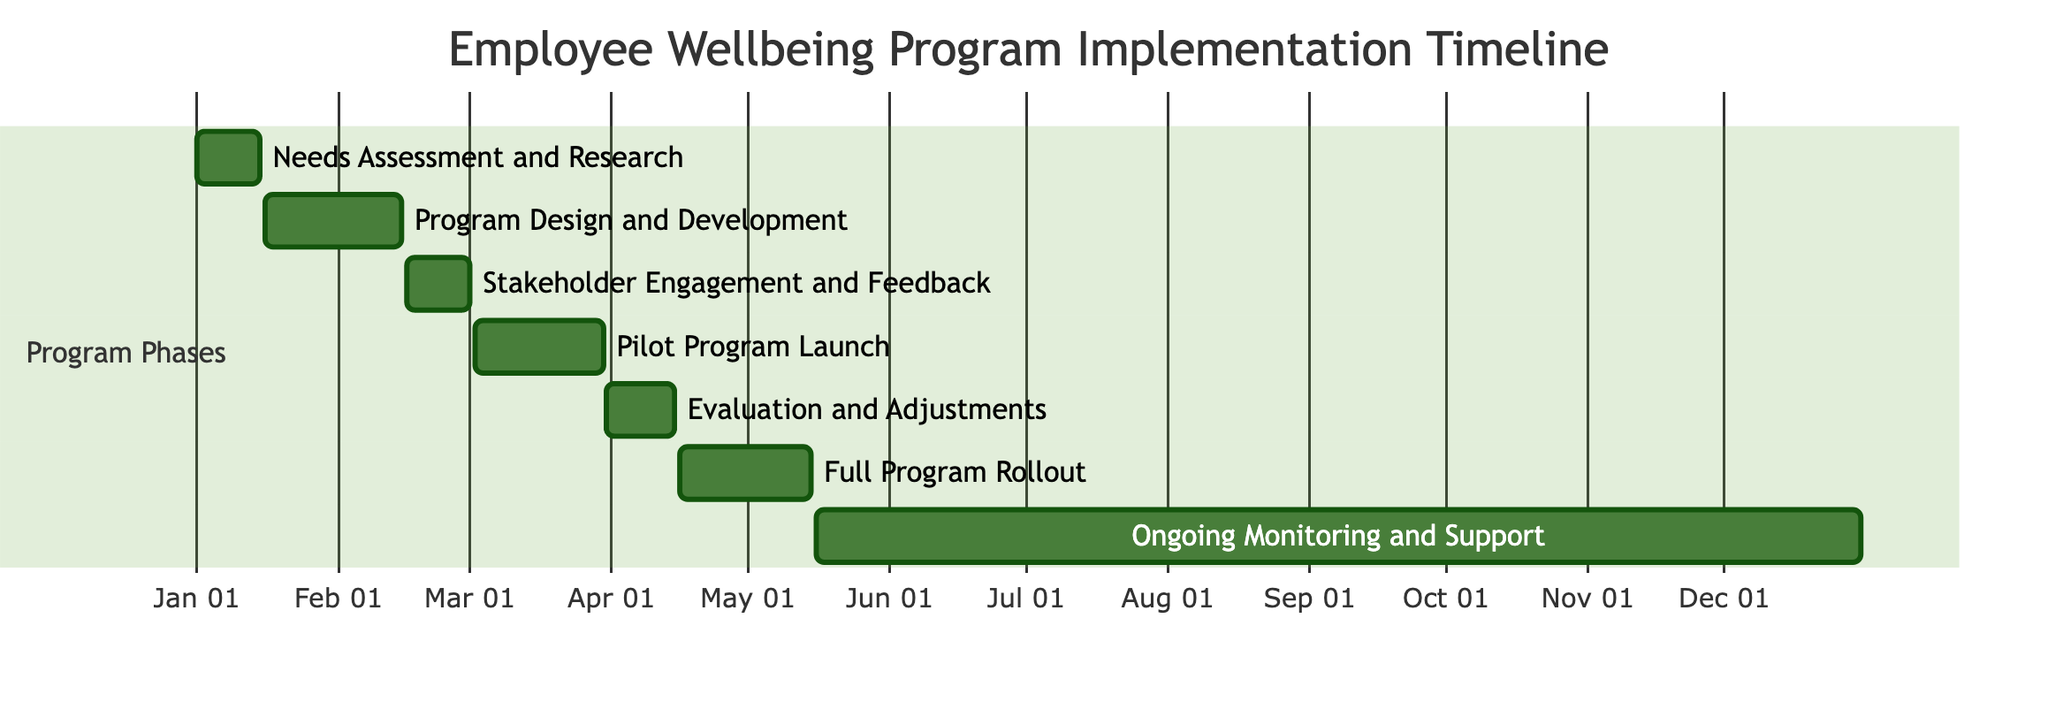What is the duration of the "Needs Assessment and Research" task? The "Needs Assessment and Research" task starts on January 1, 2024, and ends on January 15, 2024. To find the duration, we calculate the difference between the end date and start date, which is 15 days.
Answer: 15 days How many total tasks are represented in the diagram? The diagram includes a list of tasks, which can be counted directly from the timeline data provided. There are 7 tasks in total: Needs Assessment and Research, Program Design and Development, Stakeholder Engagement and Feedback, Pilot Program Launch, Evaluation and Adjustments, Full Program Rollout, and Ongoing Monitoring and Support.
Answer: 7 Which task follows the "Pilot Program Launch" in the timeline? The task immediately following the "Pilot Program Launch" (which runs from March 2, 2024, to March 30, 2024) is the "Evaluation and Adjustments" task, which starts on March 31, 2024.
Answer: Evaluation and Adjustments What is the end date of the "Full Program Rollout"? The "Full Program Rollout" task is clearly marked with its start and end dates in the timeline. It starts on April 16, 2024, and finishes on May 15, 2024. Thus, the end date is May 15, 2024.
Answer: May 15, 2024 How long does the "Ongoing Monitoring and Support" last? The "Ongoing Monitoring and Support" task starts on May 16, 2024, and ends on December 31, 2024. To determine the duration, we count the days from the start to the end date. This is a total of 229 days.
Answer: 229 days Which section of the timeline does "Stakeholder Engagement and Feedback" fall under? All tasks listed in the timeline belong to the "Program Phases" section, which is explicitly mentioned in the Gantt diagram code. Therefore, "Stakeholder Engagement and Feedback" is located in the Program Phases section.
Answer: Program Phases What comes after "Evaluation and Adjustments"? "Evaluation and Adjustments" ends on April 15, 2024, and the subsequent task that begins immediately after is the "Full Program Rollout," which starts on April 16, 2024.
Answer: Full Program Rollout 